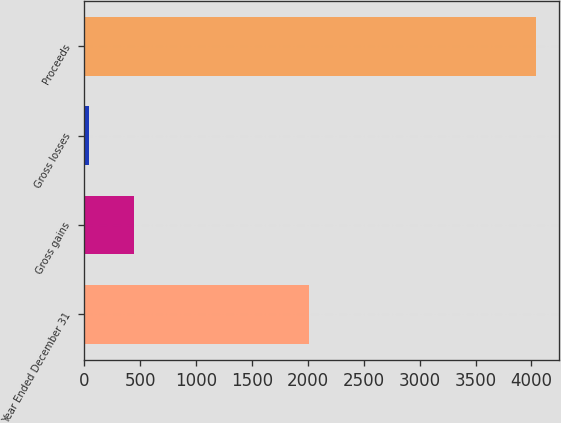Convert chart. <chart><loc_0><loc_0><loc_500><loc_500><bar_chart><fcel>Year Ended December 31<fcel>Gross gains<fcel>Gross losses<fcel>Proceeds<nl><fcel>2015<fcel>442.1<fcel>42<fcel>4043<nl></chart> 